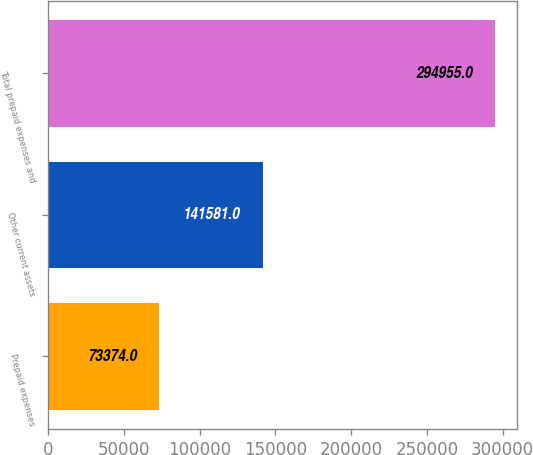<chart> <loc_0><loc_0><loc_500><loc_500><bar_chart><fcel>Prepaid expenses<fcel>Other current assets<fcel>Total prepaid expenses and<nl><fcel>73374<fcel>141581<fcel>294955<nl></chart> 